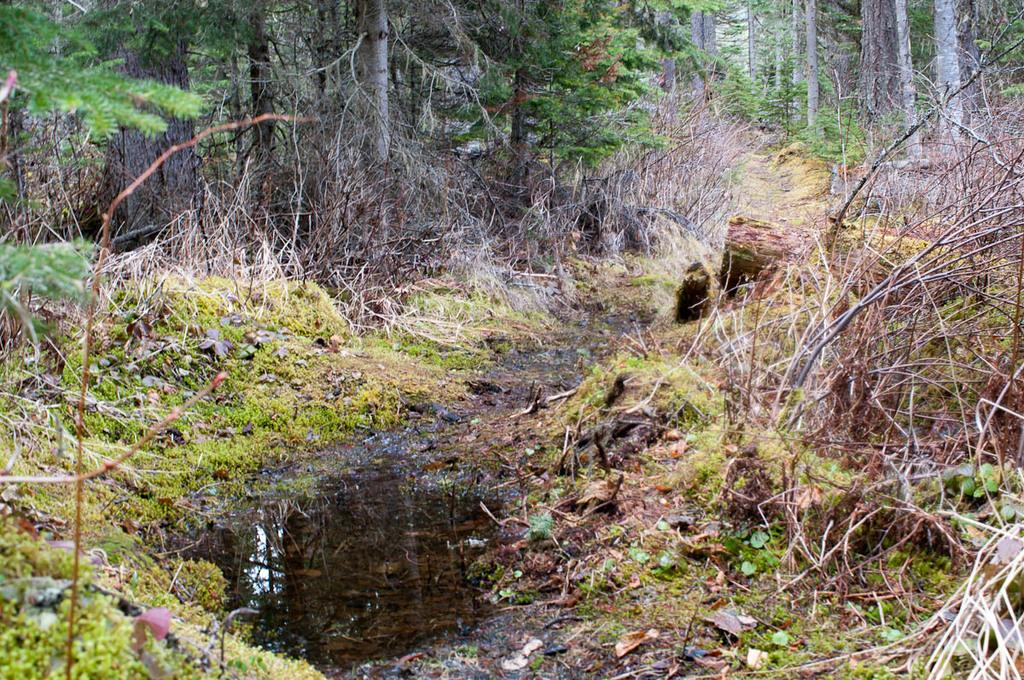What type of surface can be seen in the image? The ground is visible in the image. What is covering the ground? There is grass on the ground. What other types of vegetation are present in the image? There are plants and trees visible in the image. What else can be found on the ground in the image? Dry leaves are present in the image. What type of flag is being waved by the train in the image? There is no flag or train present in the image; it features the ground, grass, plants, trees, and dry leaves. 